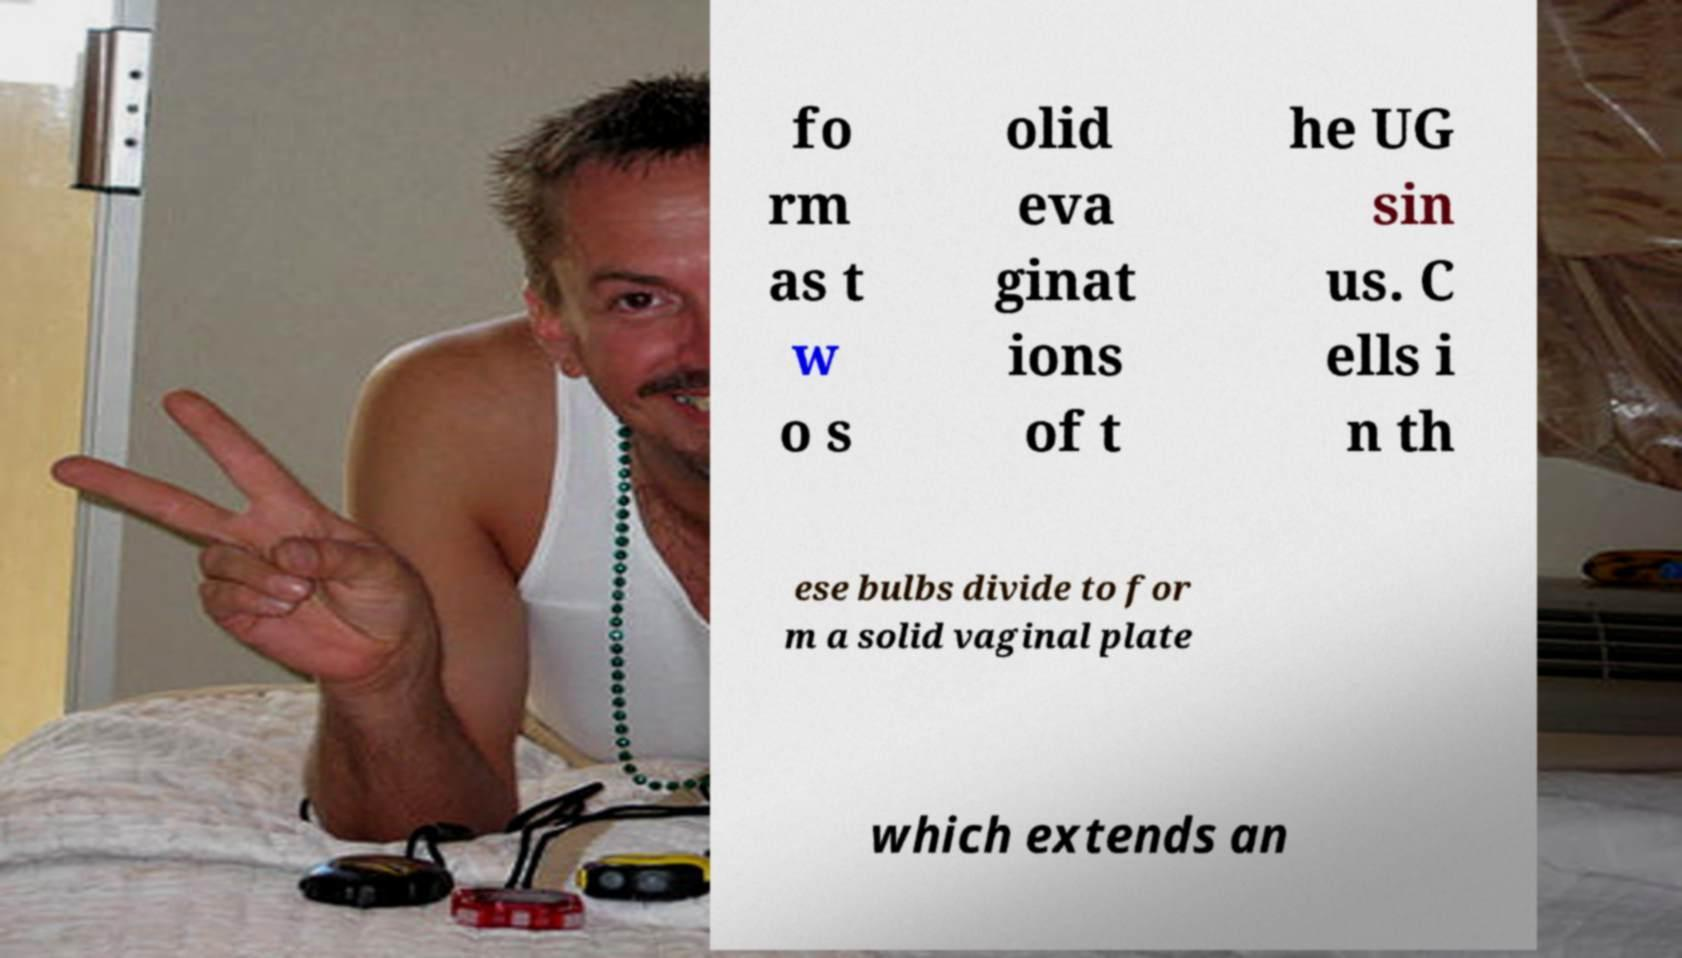Please read and relay the text visible in this image. What does it say? fo rm as t w o s olid eva ginat ions of t he UG sin us. C ells i n th ese bulbs divide to for m a solid vaginal plate which extends an 